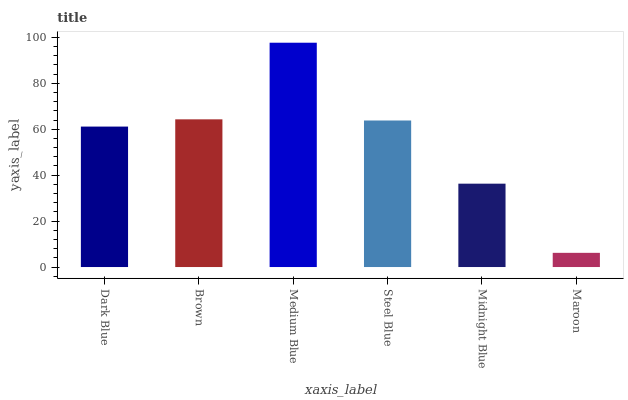Is Maroon the minimum?
Answer yes or no. Yes. Is Medium Blue the maximum?
Answer yes or no. Yes. Is Brown the minimum?
Answer yes or no. No. Is Brown the maximum?
Answer yes or no. No. Is Brown greater than Dark Blue?
Answer yes or no. Yes. Is Dark Blue less than Brown?
Answer yes or no. Yes. Is Dark Blue greater than Brown?
Answer yes or no. No. Is Brown less than Dark Blue?
Answer yes or no. No. Is Steel Blue the high median?
Answer yes or no. Yes. Is Dark Blue the low median?
Answer yes or no. Yes. Is Midnight Blue the high median?
Answer yes or no. No. Is Steel Blue the low median?
Answer yes or no. No. 